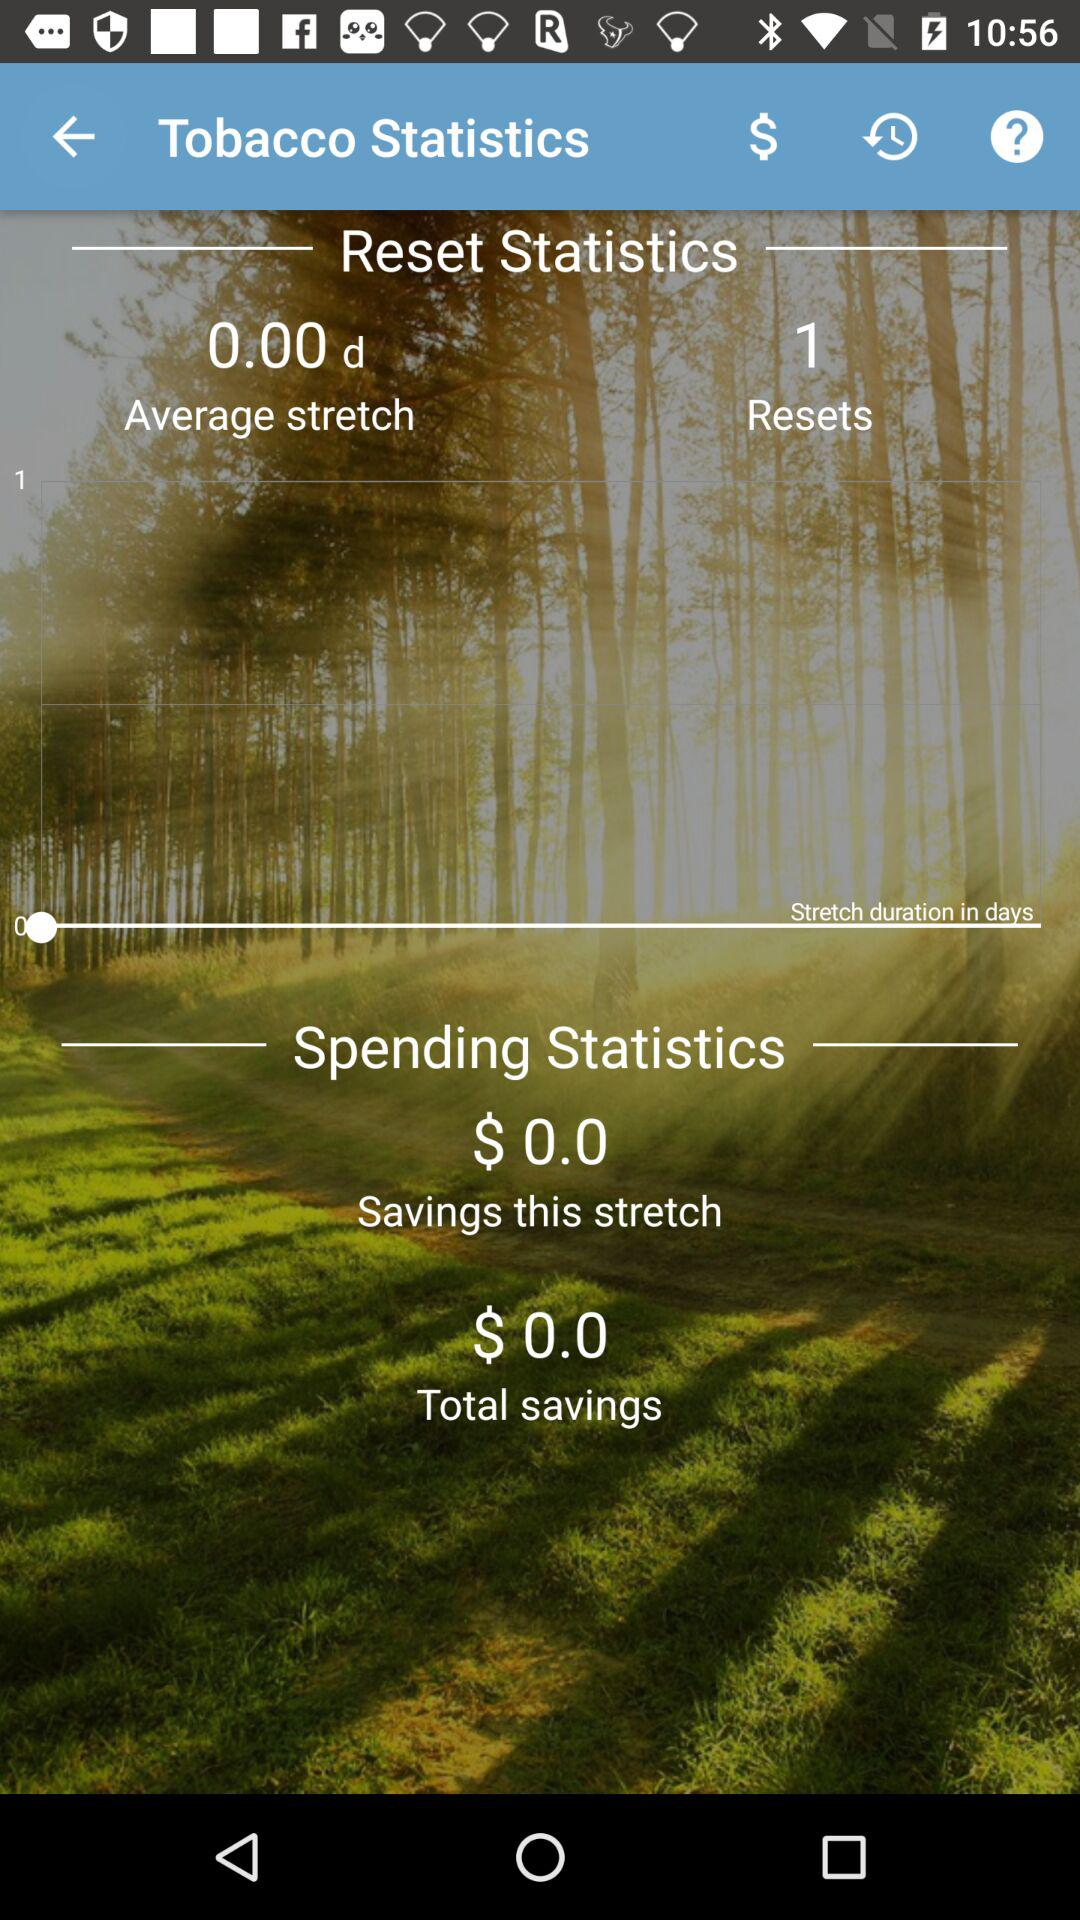What is the name of application?
When the provided information is insufficient, respond with <no answer>. <no answer> 